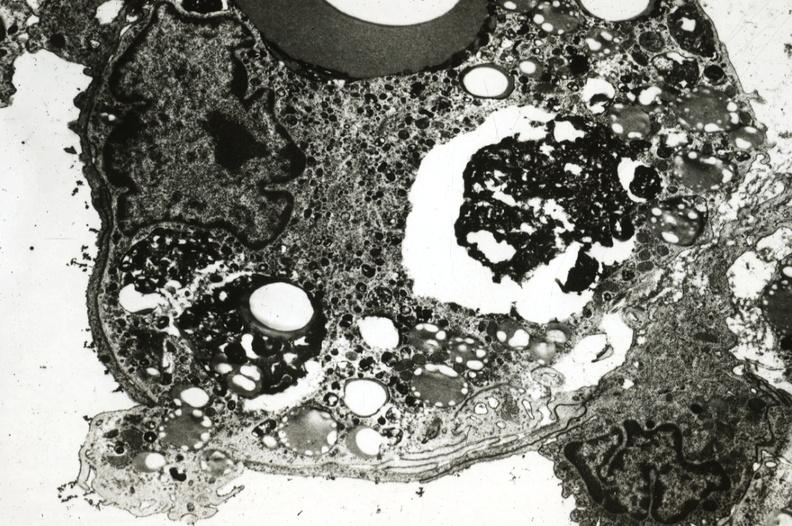what is present?
Answer the question using a single word or phrase. Cardiovascular 